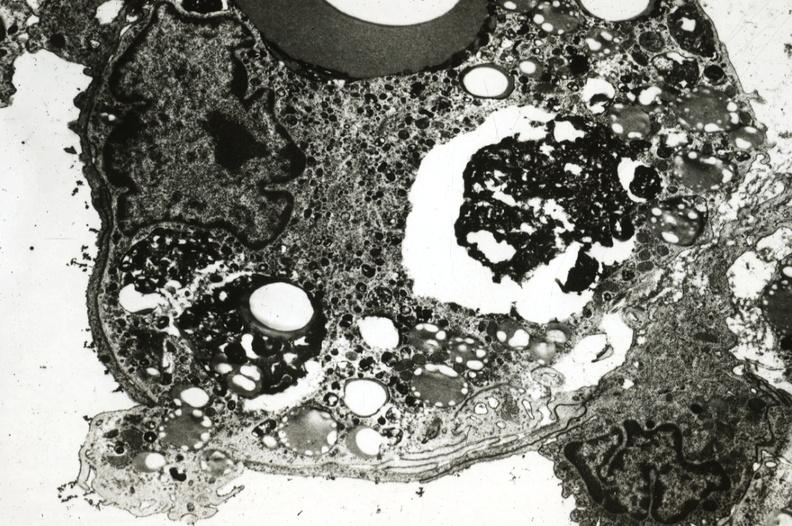what is present?
Answer the question using a single word or phrase. Cardiovascular 